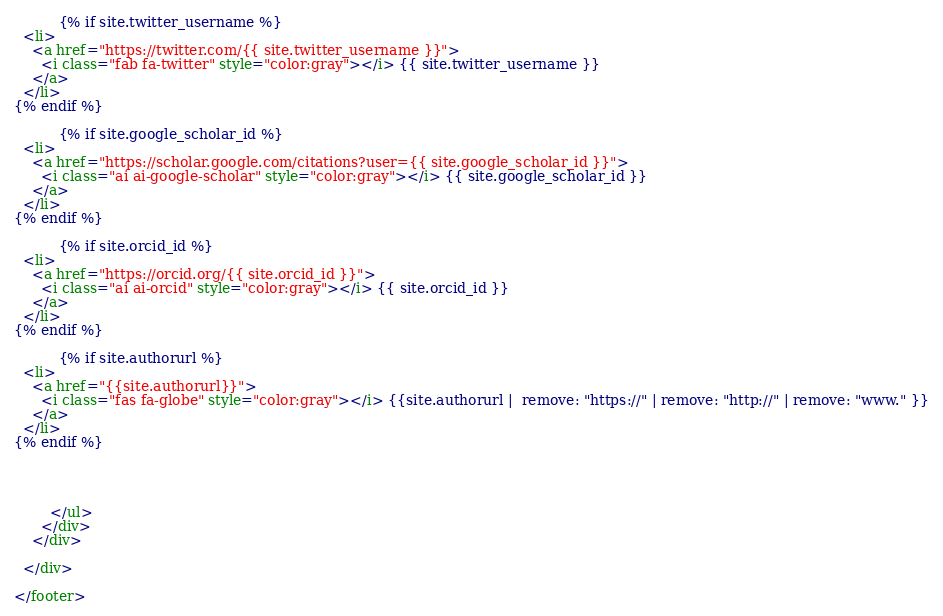Convert code to text. <code><loc_0><loc_0><loc_500><loc_500><_HTML_>          {% if site.twitter_username %}
  <li>
    <a href="https://twitter.com/{{ site.twitter_username }}">
      <i class="fab fa-twitter" style="color:gray"></i> {{ site.twitter_username }}
    </a>
  </li>
{% endif %}

          {% if site.google_scholar_id %}
  <li>
    <a href="https://scholar.google.com/citations?user={{ site.google_scholar_id }}">
      <i class="ai ai-google-scholar" style="color:gray"></i> {{ site.google_scholar_id }}
    </a>
  </li>
{% endif %}

          {% if site.orcid_id %}
  <li>
    <a href="https://orcid.org/{{ site.orcid_id }}">
      <i class="ai ai-orcid" style="color:gray"></i> {{ site.orcid_id }}
    </a>
  </li>
{% endif %}

          {% if site.authorurl %}
  <li>
    <a href="{{site.authorurl}}">
      <i class="fas fa-globe" style="color:gray"></i> {{site.authorurl |  remove: "https://" | remove: "http://" | remove: "www." }}
    </a>
  </li>
{% endif %}



       
        </ul>
      </div>
    </div>

  </div>

</footer>
</code> 